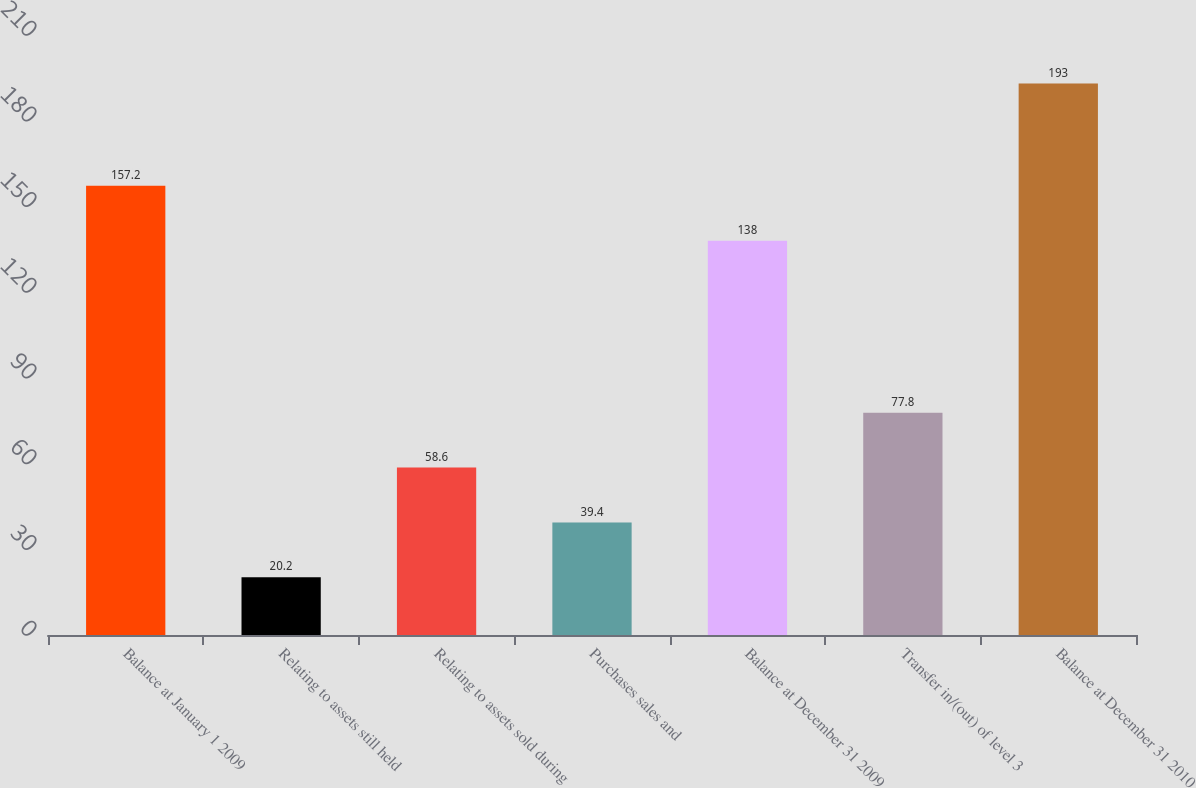Convert chart to OTSL. <chart><loc_0><loc_0><loc_500><loc_500><bar_chart><fcel>Balance at January 1 2009<fcel>Relating to assets still held<fcel>Relating to assets sold during<fcel>Purchases sales and<fcel>Balance at December 31 2009<fcel>Transfer in/(out) of level 3<fcel>Balance at December 31 2010<nl><fcel>157.2<fcel>20.2<fcel>58.6<fcel>39.4<fcel>138<fcel>77.8<fcel>193<nl></chart> 